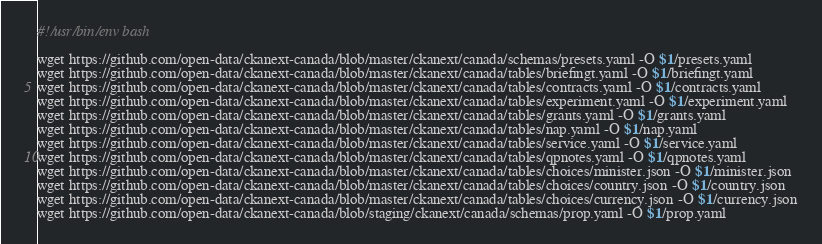Convert code to text. <code><loc_0><loc_0><loc_500><loc_500><_Bash_>#!/usr/bin/env bash

wget https://github.com/open-data/ckanext-canada/blob/master/ckanext/canada/schemas/presets.yaml -O $1/presets.yaml
wget https://github.com/open-data/ckanext-canada/blob/master/ckanext/canada/tables/briefingt.yaml -O $1/briefingt.yaml
wget https://github.com/open-data/ckanext-canada/blob/master/ckanext/canada/tables/contracts.yaml -O $1/contracts.yaml
wget https://github.com/open-data/ckanext-canada/blob/master/ckanext/canada/tables/experiment.yaml -O $1/experiment.yaml
wget https://github.com/open-data/ckanext-canada/blob/master/ckanext/canada/tables/grants.yaml -O $1/grants.yaml
wget https://github.com/open-data/ckanext-canada/blob/master/ckanext/canada/tables/nap.yaml -O $1/nap.yaml
wget https://github.com/open-data/ckanext-canada/blob/master/ckanext/canada/tables/service.yaml -O $1/service.yaml
wget https://github.com/open-data/ckanext-canada/blob/master/ckanext/canada/tables/qpnotes.yaml -O $1/qpnotes.yaml
wget https://github.com/open-data/ckanext-canada/blob/master/ckanext/canada/tables/choices/minister.json -O $1/minister.json
wget https://github.com/open-data/ckanext-canada/blob/master/ckanext/canada/tables/choices/country.json -O $1/country.json
wget https://github.com/open-data/ckanext-canada/blob/master/ckanext/canada/tables/choices/currency.json -O $1/currency.json
wget https://github.com/open-data/ckanext-canada/blob/staging/ckanext/canada/schemas/prop.yaml -O $1/prop.yaml
</code> 